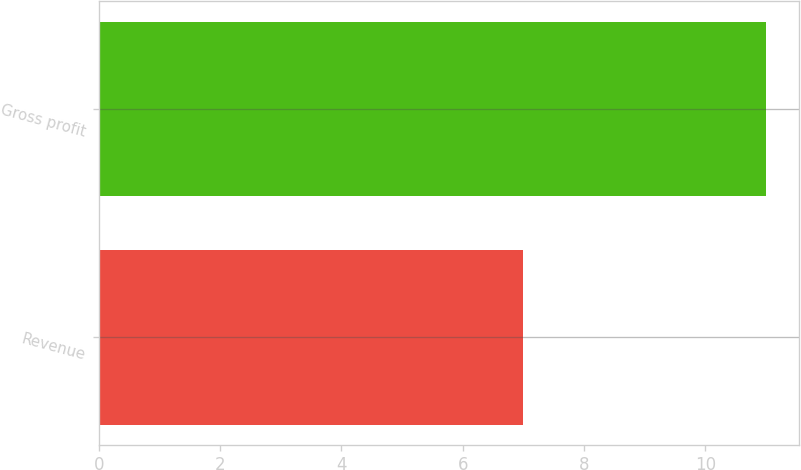Convert chart. <chart><loc_0><loc_0><loc_500><loc_500><bar_chart><fcel>Revenue<fcel>Gross profit<nl><fcel>7<fcel>11<nl></chart> 